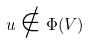<formula> <loc_0><loc_0><loc_500><loc_500>u \notin \Phi ( V )</formula> 